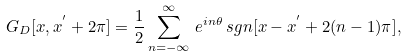<formula> <loc_0><loc_0><loc_500><loc_500>G _ { D } [ x , x ^ { ^ { \prime } } + 2 \pi ] = \frac { 1 } { 2 } \sum _ { n = - \infty } ^ { \infty } \, e ^ { i n \theta } \, s g n [ x - x ^ { ^ { \prime } } + 2 ( n - 1 ) \pi ] ,</formula> 